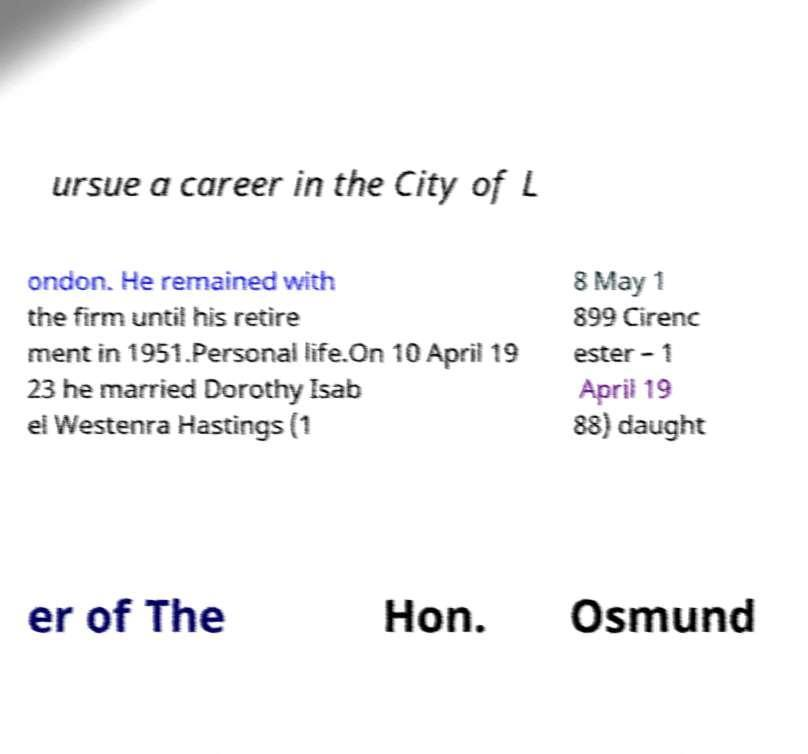For documentation purposes, I need the text within this image transcribed. Could you provide that? ursue a career in the City of L ondon. He remained with the firm until his retire ment in 1951.Personal life.On 10 April 19 23 he married Dorothy Isab el Westenra Hastings (1 8 May 1 899 Cirenc ester – 1 April 19 88) daught er of The Hon. Osmund 